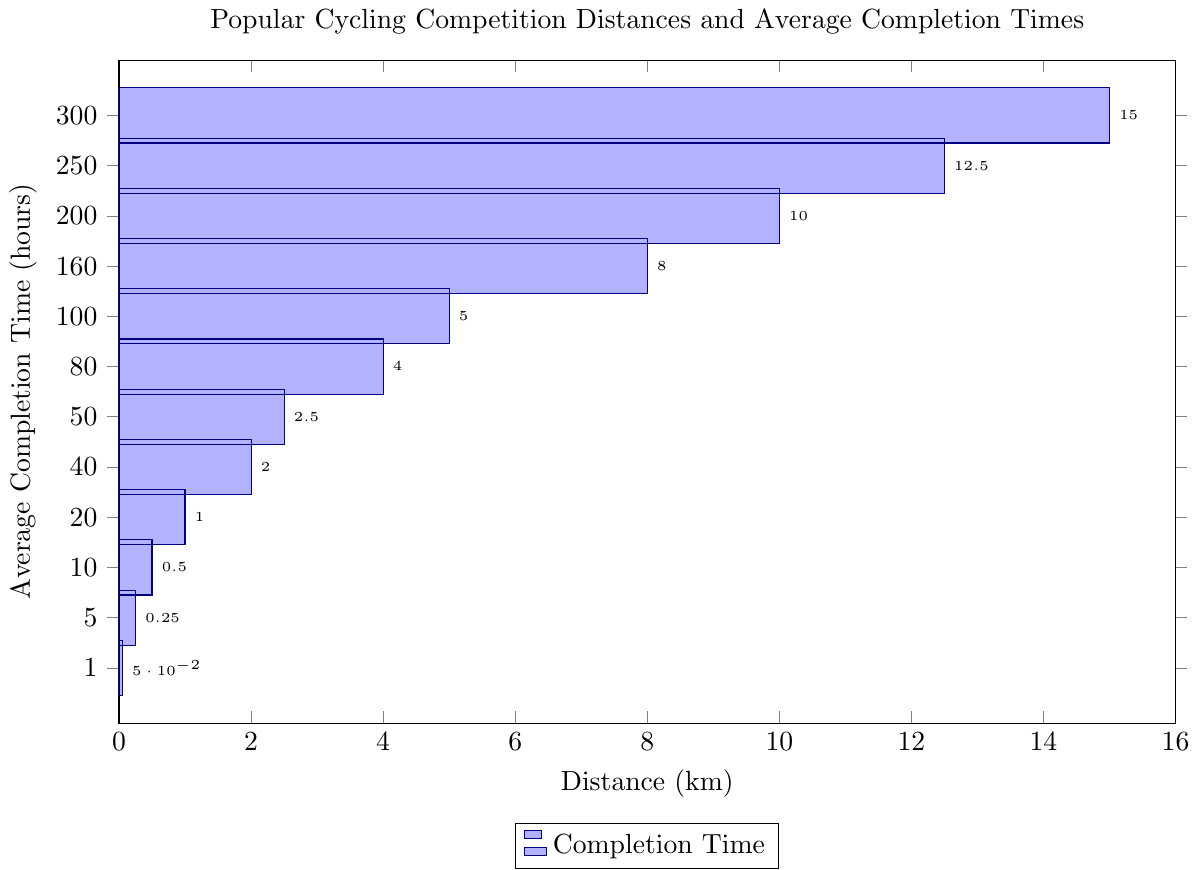What is the average completion time for a 100 km cycling competition? The figure shows that the bar representing 100 km has a length corresponding to an average completion time of 5 hours.
Answer: 5 hours Which distance has the shortest average completion time, and what is that time? The shortest bar represents the distance of 1 km, with an average completion time of 0.05 hours.
Answer: 1 km, 0.05 hours By how many hours does the average completion time for a 200 km competition exceed that for a 100 km competition? The average completion time for 200 km is 10 hours, and for 100 km, it is 5 hours. The difference is 10 - 5 = 5 hours.
Answer: 5 hours Which distance has the highest average completion time? The highest bar corresponds to the 300 km distance, with an average completion time of 15 hours.
Answer: 300 km What is the total average completion time for the 10 km, 20 km, and 40 km distances? The times are 0.5 hours for 10 km, 1 hour for 20 km, and 2 hours for 40 km. Summing these gives 0.5 + 1 + 2 = 3.5 hours.
Answer: 3.5 hours How much longer is the average completion time for an 80 km competition compared to a 20 km competition? The average completion time for 80 km is 4 hours, and for 20 km, it is 1 hour. The difference is 4 - 1 = 3 hours.
Answer: 3 hours For which two consecutive distances is the difference in average completion time the greatest, and what is the difference? The highest difference is between 200 km (10 hours) and 250 km (12.5 hours), with a difference of 12.5 - 10 = 2.5 hours.
Answer: 200 km and 250 km, 2.5 hours What is the average completion time for distances less than or equal to 20 km? The distances are 1 km, 5 km, 10 km, and 20 km with times 0.05, 0.25, 0.5, and 1 hour respectively. The average is (0.05 + 0.25 + 0.5 + 1) / 4 = 1.8 / 4 = 0.45 hours.
Answer: 0.45 hours Is the average completion time for a 250 km competition more or less than three times that for a 80 km competition? Three times the completion time for 80 km (4 hours) is 3 * 4 = 12 hours. The time for 250 km is 12.5 hours, which is more than 12 hours.
Answer: More 